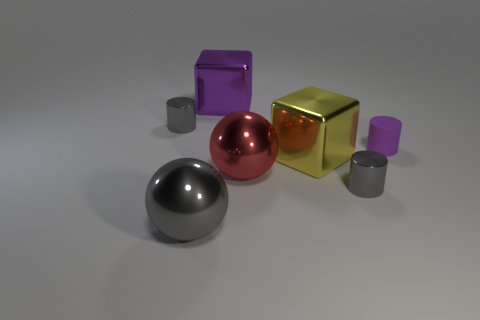How many big purple blocks are on the left side of the small gray shiny cylinder that is to the left of the big purple object?
Your answer should be very brief. 0. Do the cube that is left of the large red thing and the small matte thing have the same color?
Provide a short and direct response. Yes. How many objects are either big shiny objects or small shiny objects that are behind the big red ball?
Give a very brief answer. 5. Is the shape of the small gray object that is to the left of the large purple shiny thing the same as the small thing in front of the big red sphere?
Make the answer very short. Yes. Are there any other things of the same color as the rubber cylinder?
Ensure brevity in your answer.  Yes. There is a large gray thing that is the same material as the big red ball; what shape is it?
Provide a short and direct response. Sphere. What is the material of the small thing that is right of the big red metallic ball and behind the big red thing?
Make the answer very short. Rubber. The big thing that is the same color as the matte cylinder is what shape?
Offer a terse response. Cube. How many other objects have the same shape as the small purple object?
Offer a very short reply. 2. The yellow thing that is the same material as the large red sphere is what size?
Ensure brevity in your answer.  Large. 